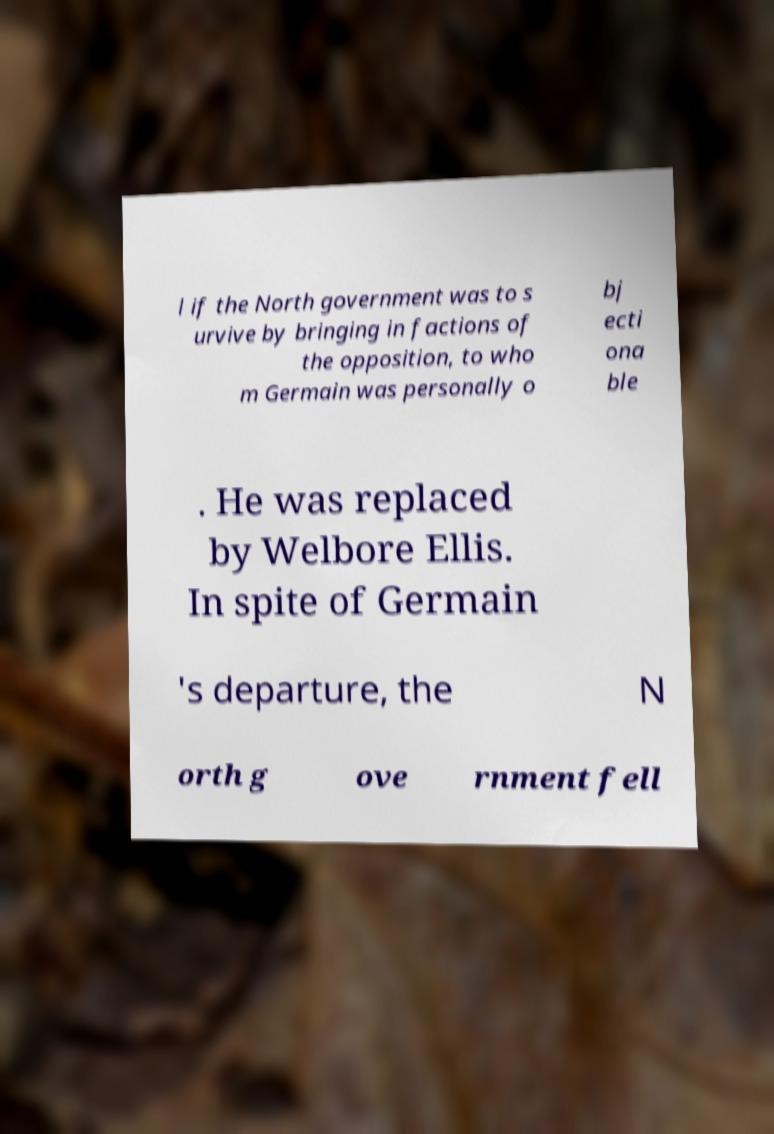What messages or text are displayed in this image? I need them in a readable, typed format. l if the North government was to s urvive by bringing in factions of the opposition, to who m Germain was personally o bj ecti ona ble . He was replaced by Welbore Ellis. In spite of Germain 's departure, the N orth g ove rnment fell 